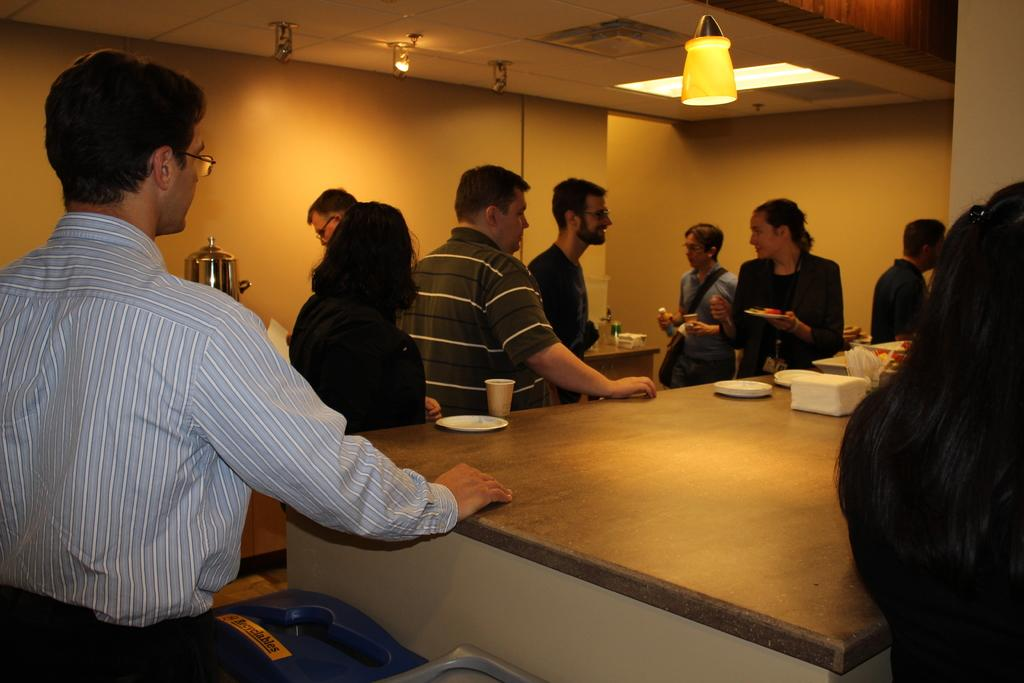How many people are in the image? There is a group of people in the image. Can you describe any interactions between the people? Two people are speaking to each other. What type of playground equipment can be seen in the image? There is no playground equipment present in the image. What government policies are being discussed by the people in the image? The image does not provide any information about the content of the conversation between the two people. 